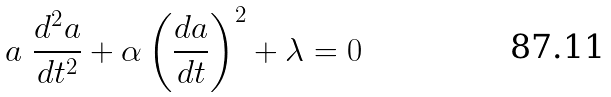<formula> <loc_0><loc_0><loc_500><loc_500>a \ \frac { d ^ { 2 } a } { d t ^ { 2 } } + \alpha \left ( \frac { d a } { d t } \right ) ^ { 2 } + \lambda = 0</formula> 